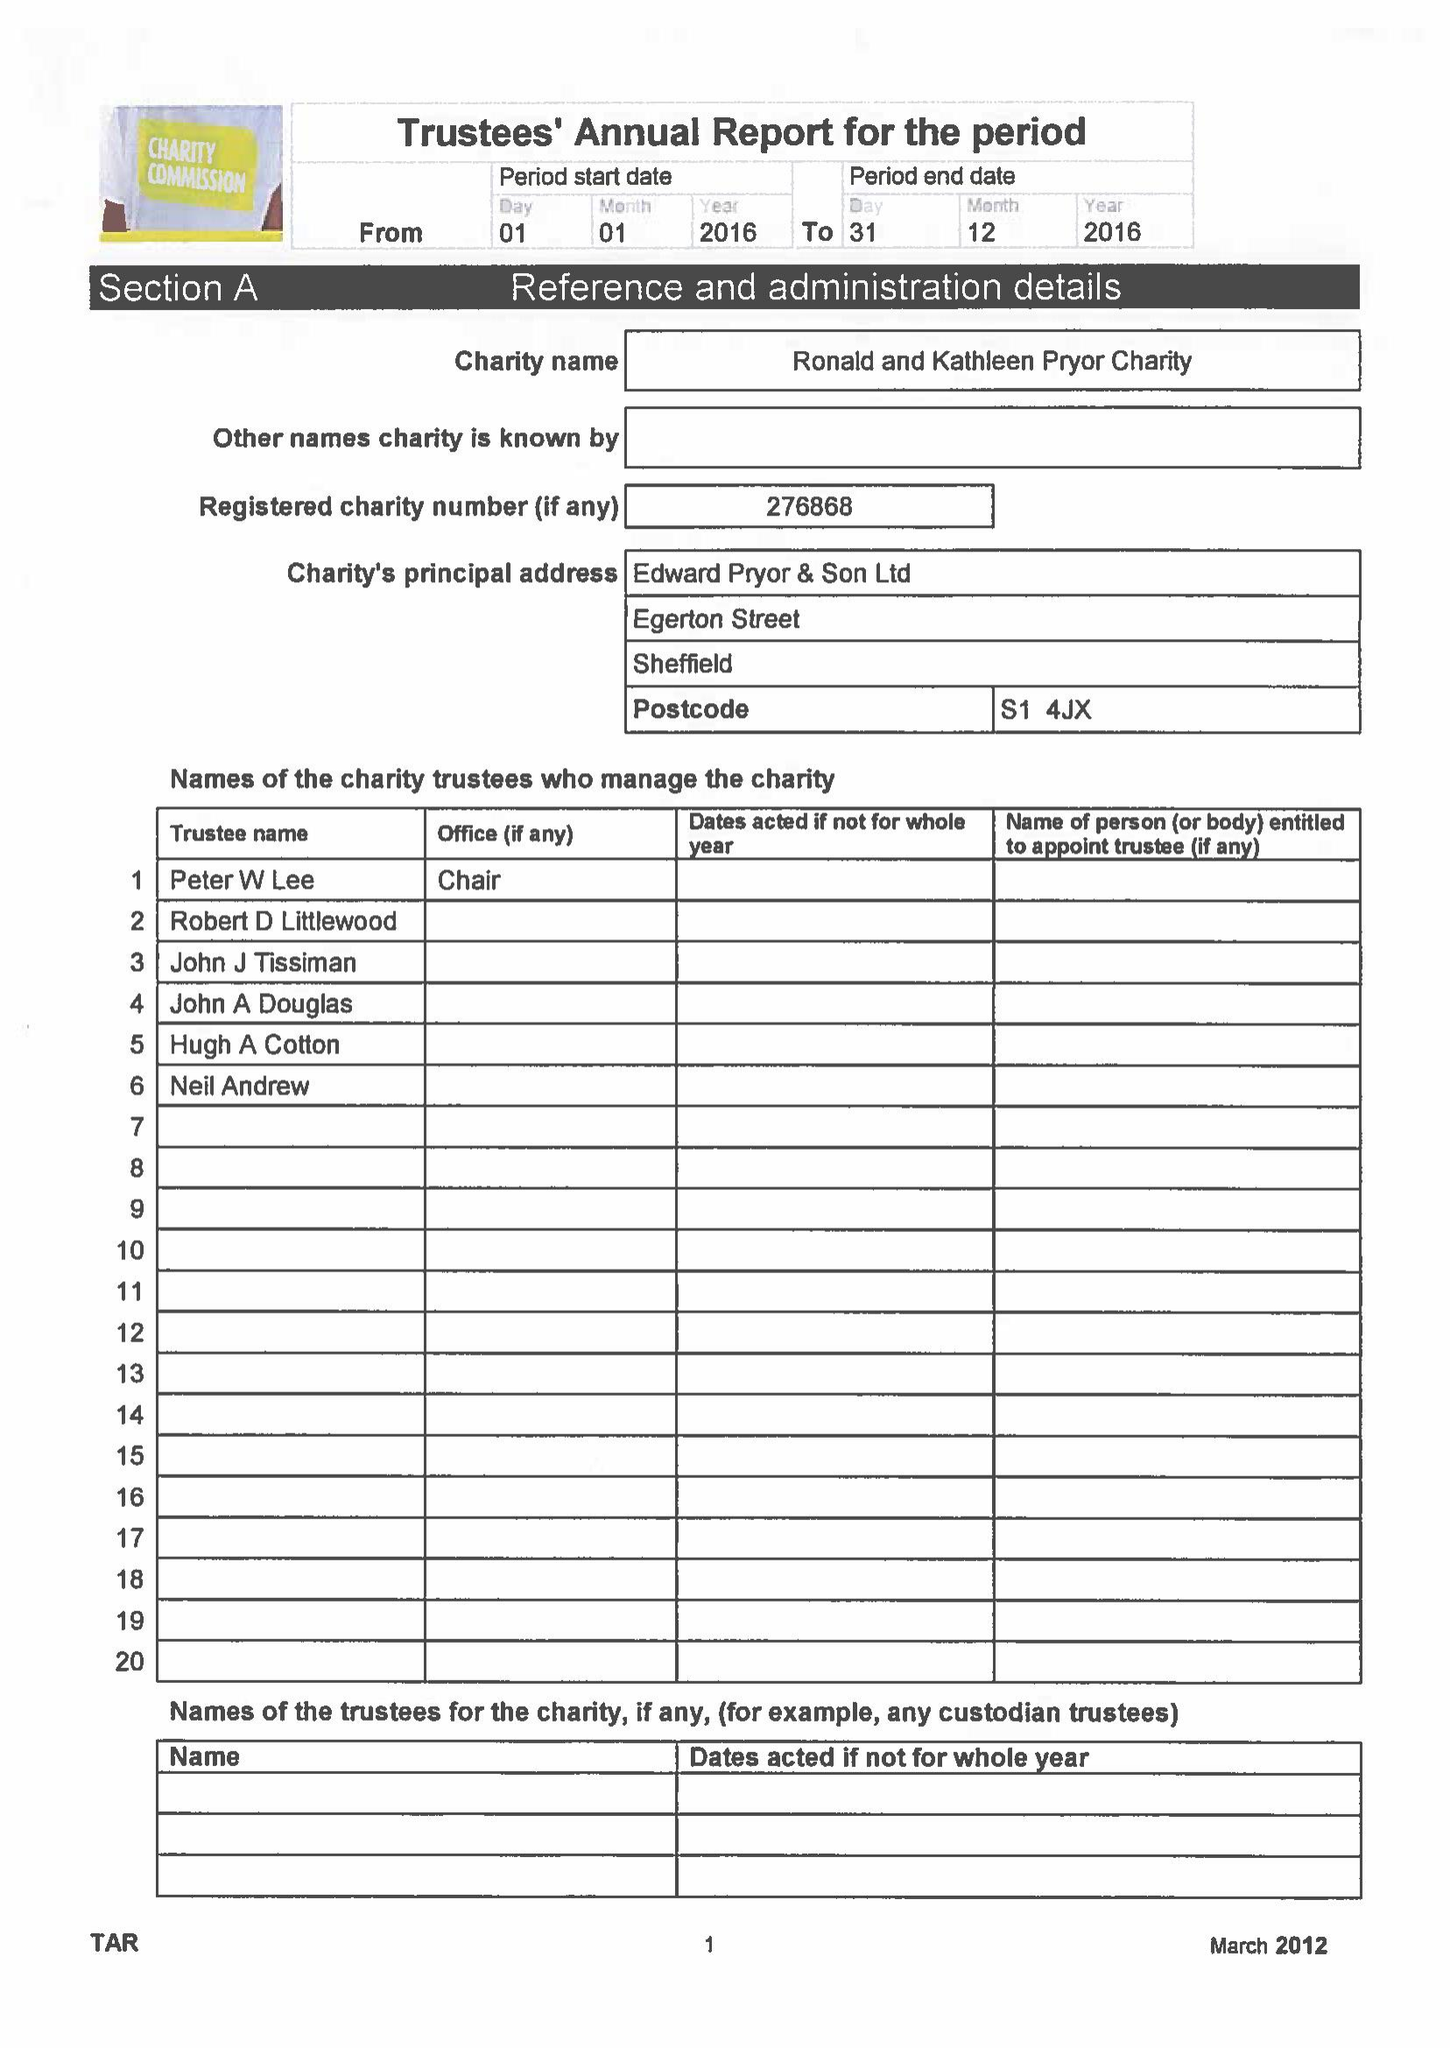What is the value for the address__postcode?
Answer the question using a single word or phrase. S1 4JX 